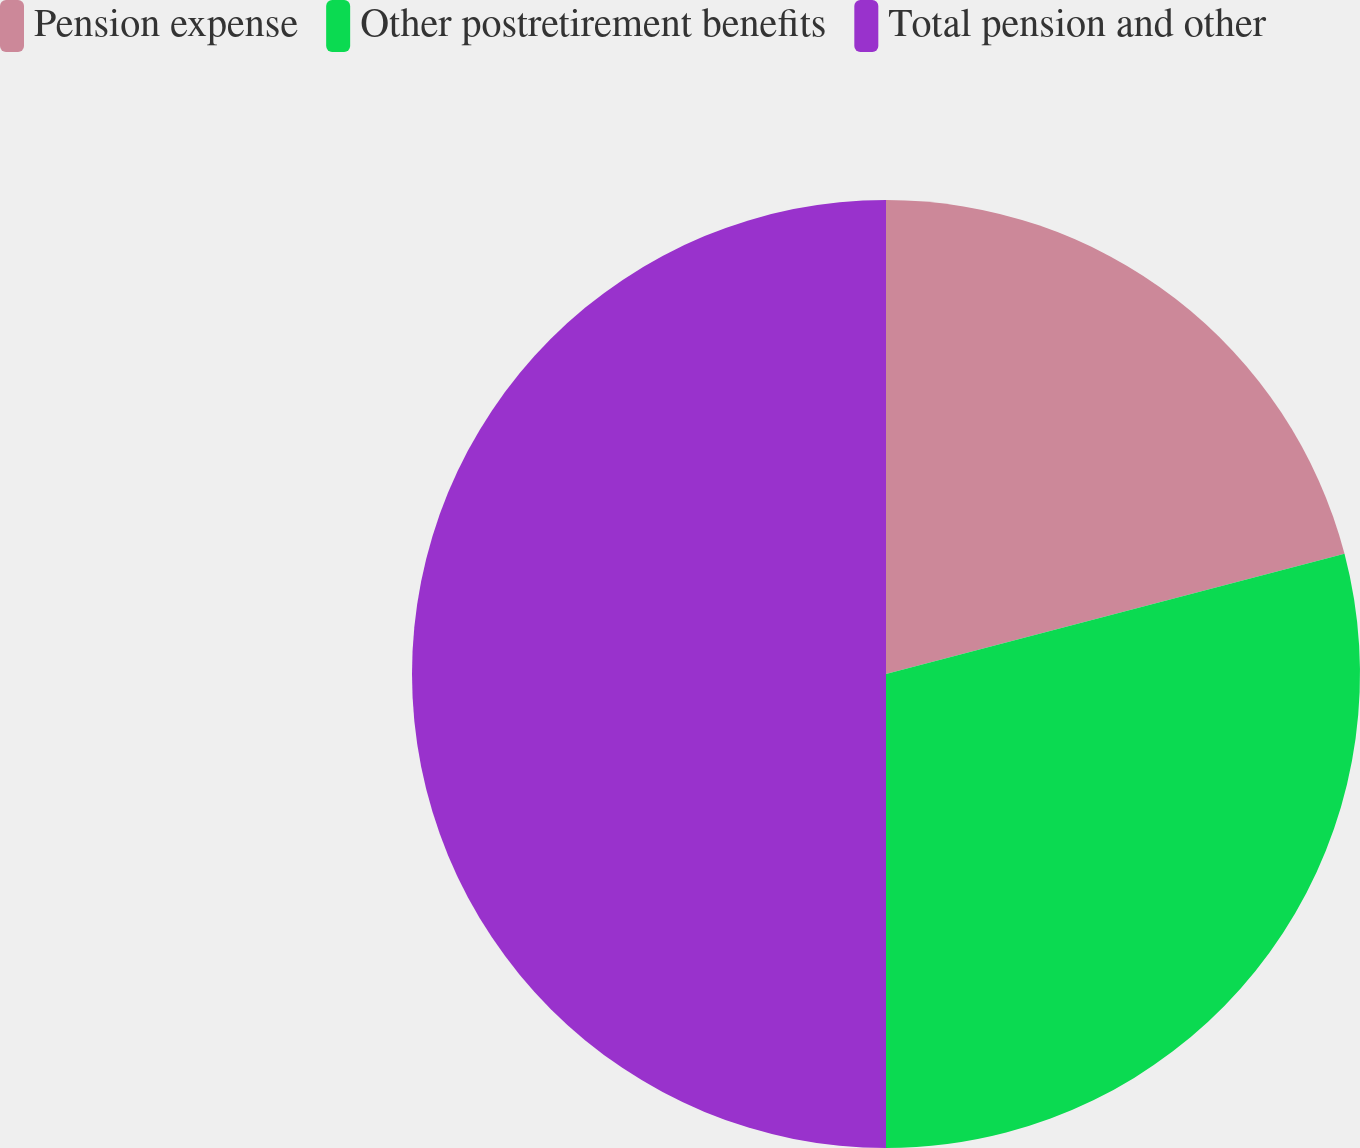Convert chart. <chart><loc_0><loc_0><loc_500><loc_500><pie_chart><fcel>Pension expense<fcel>Other postretirement benefits<fcel>Total pension and other<nl><fcel>20.92%<fcel>29.08%<fcel>50.0%<nl></chart> 